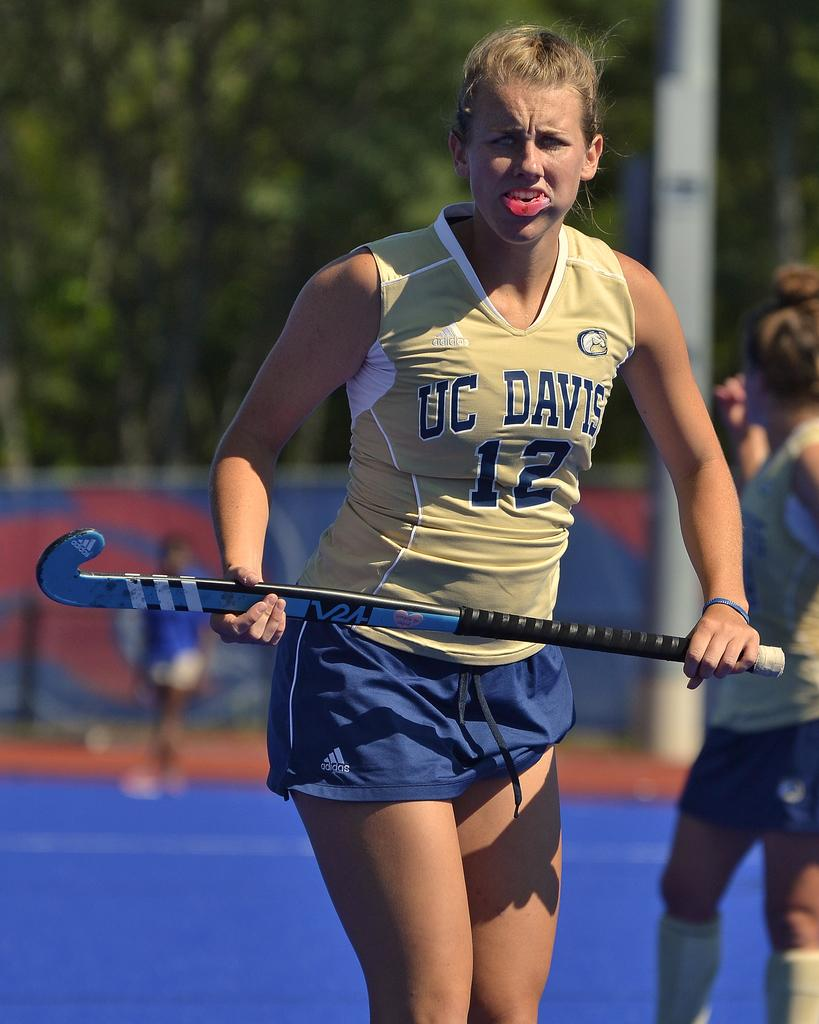How many people are in the image? There are people in the image, but the exact number is not specified. What is one person doing in the image? One person is holding an object in the image. What can be seen beneath the people in the image? The ground is visible in the image. Can you describe the background of the image? The background is blurred in the image. What type of neck can be seen in the image? There is no neck visible in the image. What is being exchanged between the people in the image? The facts do not mention any exchange between the people in the image. How many marbles are present in the image? There is no mention of marbles in the image. 